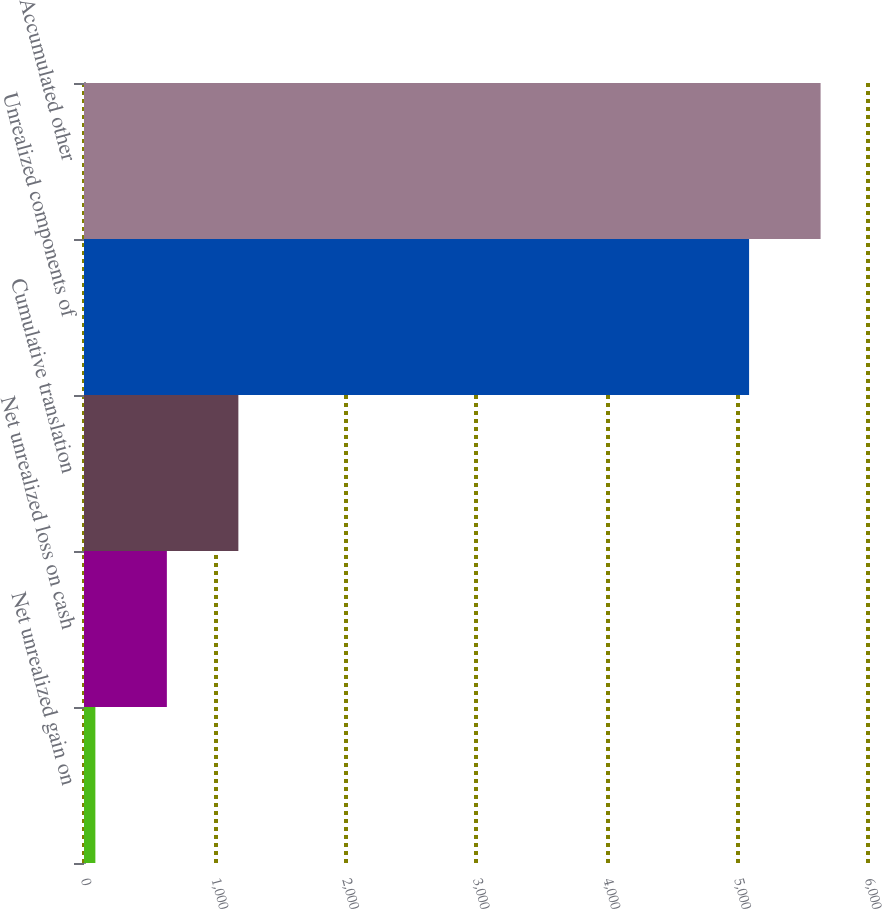Convert chart to OTSL. <chart><loc_0><loc_0><loc_500><loc_500><bar_chart><fcel>Net unrealized gain on<fcel>Net unrealized loss on cash<fcel>Cumulative translation<fcel>Unrealized components of<fcel>Accumulated other<nl><fcel>87<fcel>634.2<fcel>1181.4<fcel>5090<fcel>5637.2<nl></chart> 